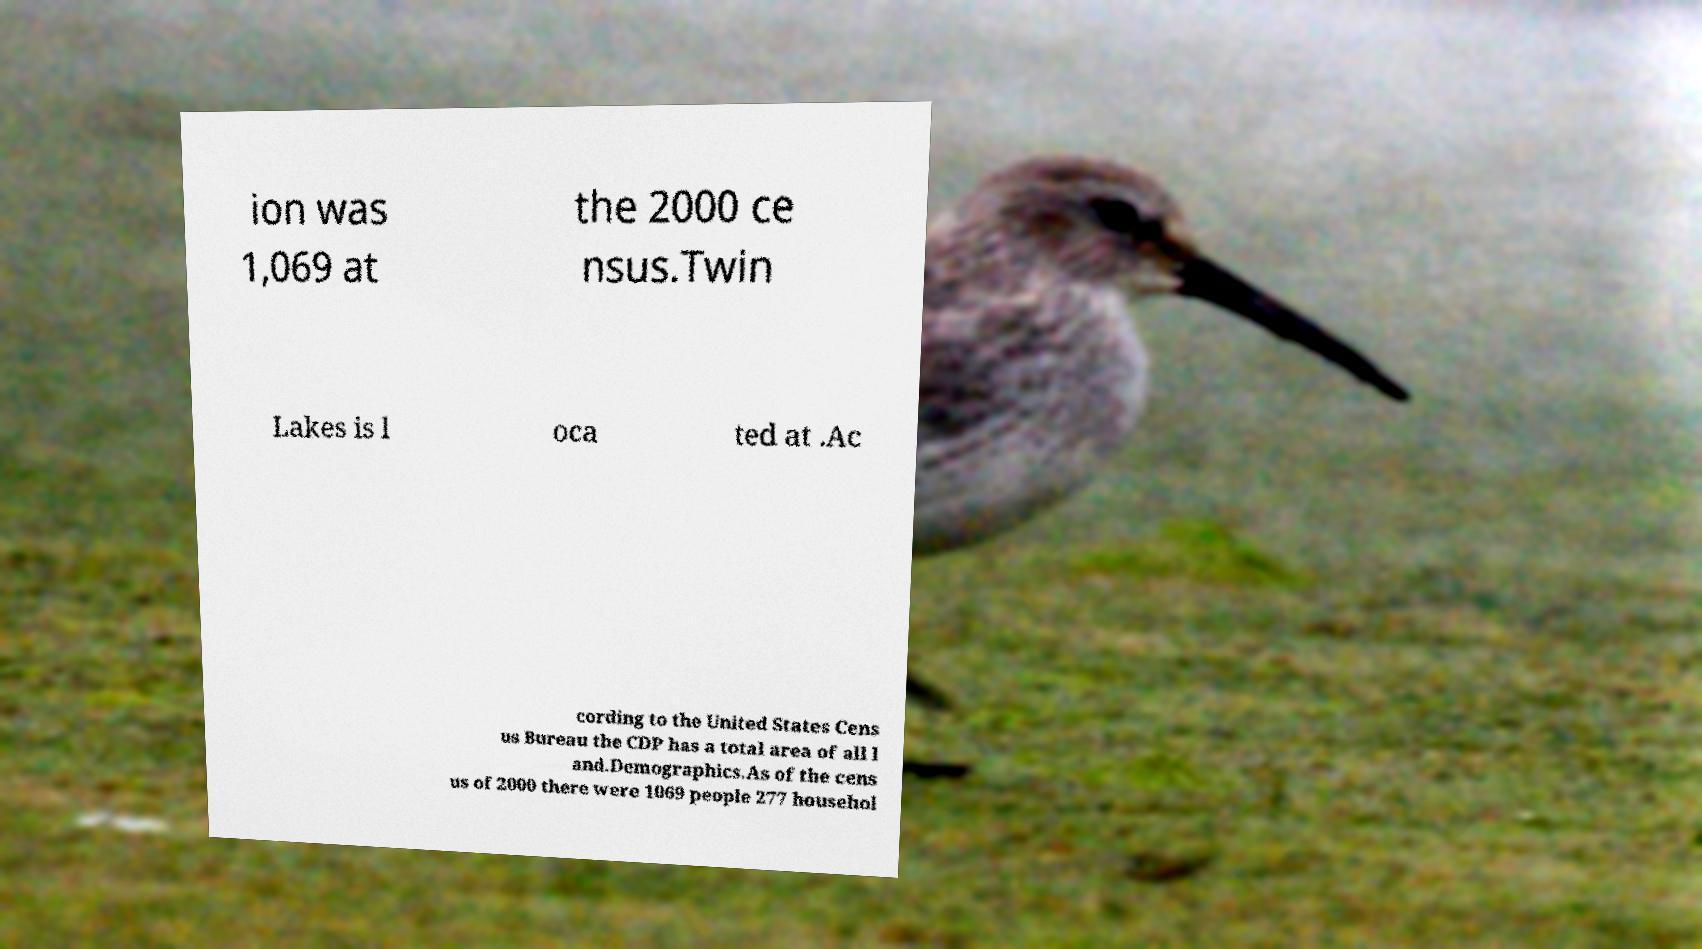Could you assist in decoding the text presented in this image and type it out clearly? ion was 1,069 at the 2000 ce nsus.Twin Lakes is l oca ted at .Ac cording to the United States Cens us Bureau the CDP has a total area of all l and.Demographics.As of the cens us of 2000 there were 1069 people 277 househol 